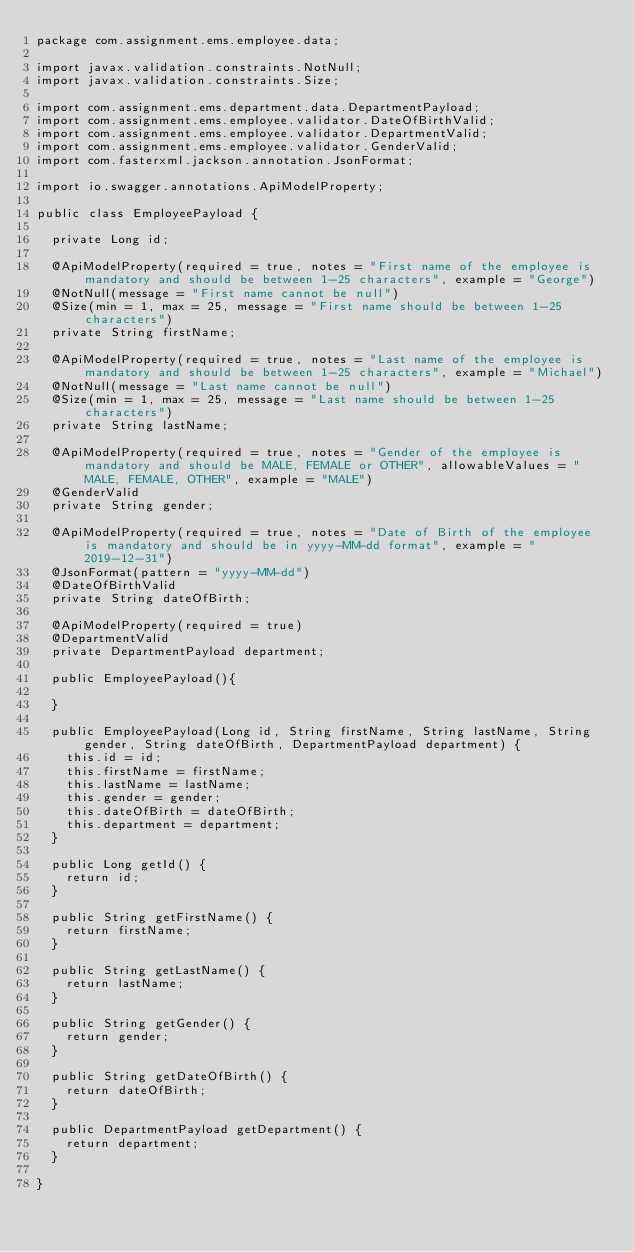Convert code to text. <code><loc_0><loc_0><loc_500><loc_500><_Java_>package com.assignment.ems.employee.data;

import javax.validation.constraints.NotNull;
import javax.validation.constraints.Size;

import com.assignment.ems.department.data.DepartmentPayload;
import com.assignment.ems.employee.validator.DateOfBirthValid;
import com.assignment.ems.employee.validator.DepartmentValid;
import com.assignment.ems.employee.validator.GenderValid;
import com.fasterxml.jackson.annotation.JsonFormat;

import io.swagger.annotations.ApiModelProperty;

public class EmployeePayload {
	
	private Long id;

	@ApiModelProperty(required = true, notes = "First name of the employee is mandatory and should be between 1-25 characters", example = "George")
	@NotNull(message = "First name cannot be null")
	@Size(min = 1, max = 25, message = "First name should be between 1-25 characters")
	private String firstName;
	
	@ApiModelProperty(required = true, notes = "Last name of the employee is mandatory and should be between 1-25 characters", example = "Michael")
	@NotNull(message = "Last name cannot be null")
	@Size(min = 1, max = 25, message = "Last name should be between 1-25 characters")
	private String lastName;
	
	@ApiModelProperty(required = true, notes = "Gender of the employee is mandatory and should be MALE, FEMALE or OTHER", allowableValues = "MALE, FEMALE, OTHER", example = "MALE")
	@GenderValid
	private String gender;
	
	@ApiModelProperty(required = true, notes = "Date of Birth of the employee is mandatory and should be in yyyy-MM-dd format", example = "2019-12-31")
	@JsonFormat(pattern = "yyyy-MM-dd")
	@DateOfBirthValid
	private String dateOfBirth;
	
	@ApiModelProperty(required = true)
	@DepartmentValid
	private DepartmentPayload department;
	
	public EmployeePayload(){
		
	}

	public EmployeePayload(Long id, String firstName, String lastName, String gender, String dateOfBirth, DepartmentPayload department) {
		this.id = id;
		this.firstName = firstName;
		this.lastName = lastName;
		this.gender = gender;
		this.dateOfBirth = dateOfBirth;
		this.department = department;
	}

	public Long getId() {
		return id;
	}

	public String getFirstName() {
		return firstName;
	}

	public String getLastName() {
		return lastName;
	}

	public String getGender() {
		return gender;
	}

	public String getDateOfBirth() {
		return dateOfBirth;
	}

	public DepartmentPayload getDepartment() {
		return department;
	}

}
</code> 